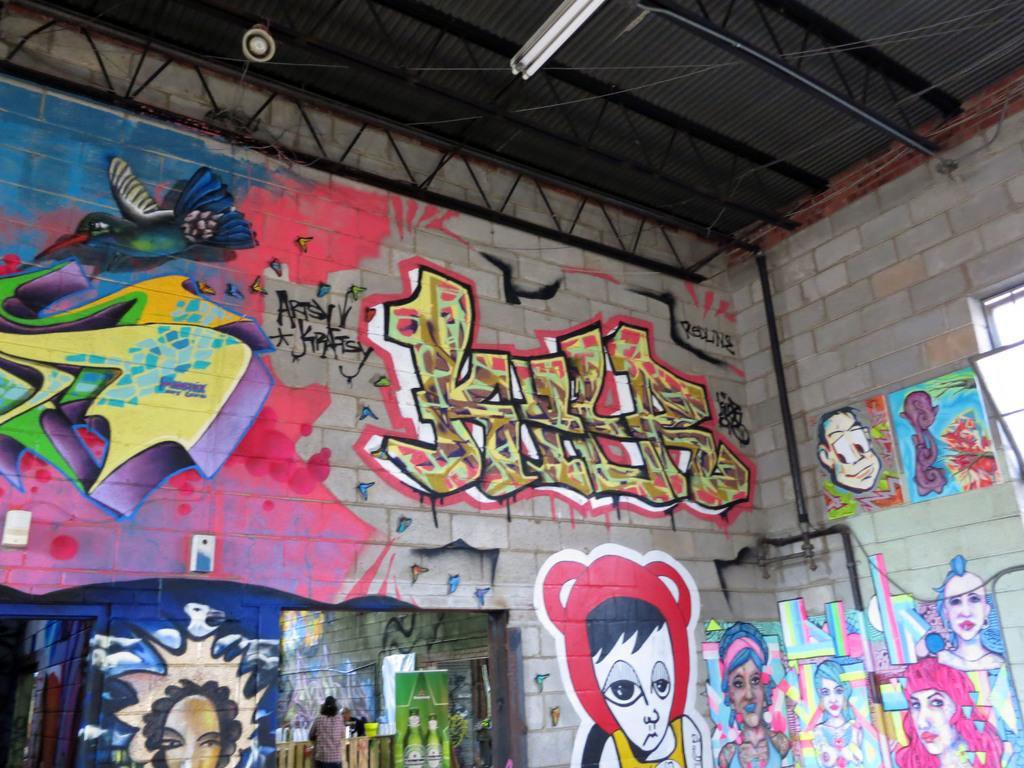How would you summarize this image in a sentence or two? In the image there is a wall with different types of graffiti. And also on the wall there is a black pipe. At the top of the image there is a roof with rods and also there is a tube light. 